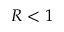Convert formula to latex. <formula><loc_0><loc_0><loc_500><loc_500>R < 1</formula> 